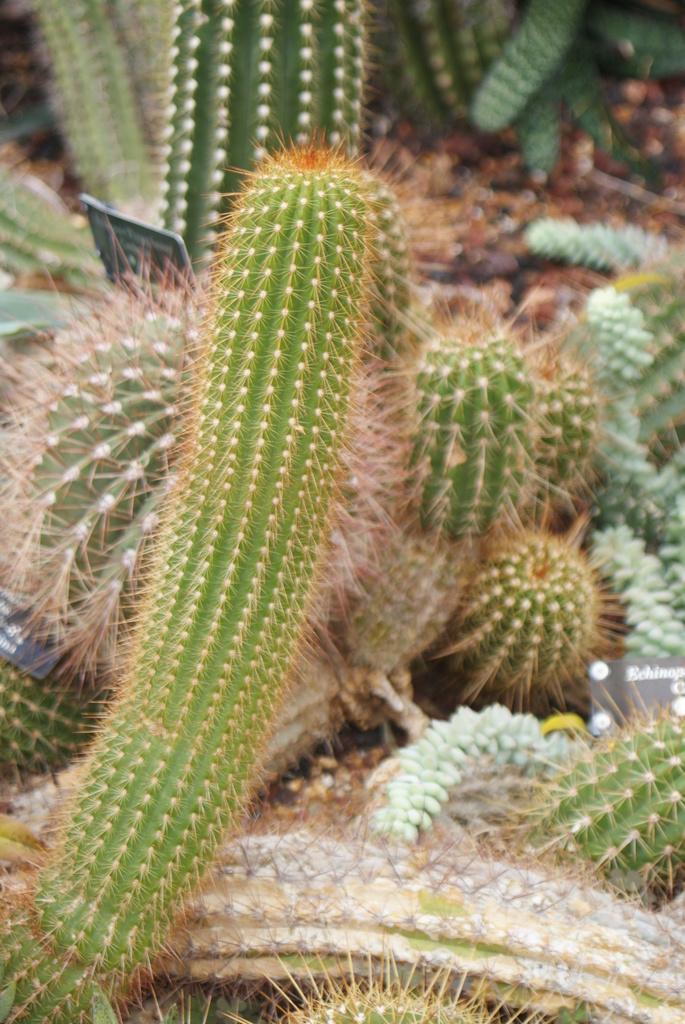How would you summarize this image in a sentence or two? In this picture I can see cactus plants and a small board with some text. 